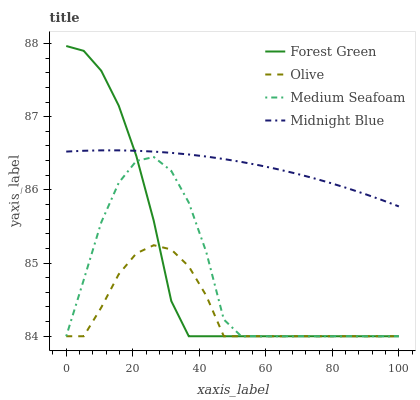Does Olive have the minimum area under the curve?
Answer yes or no. Yes. Does Midnight Blue have the maximum area under the curve?
Answer yes or no. Yes. Does Forest Green have the minimum area under the curve?
Answer yes or no. No. Does Forest Green have the maximum area under the curve?
Answer yes or no. No. Is Midnight Blue the smoothest?
Answer yes or no. Yes. Is Medium Seafoam the roughest?
Answer yes or no. Yes. Is Forest Green the smoothest?
Answer yes or no. No. Is Forest Green the roughest?
Answer yes or no. No. Does Olive have the lowest value?
Answer yes or no. Yes. Does Midnight Blue have the lowest value?
Answer yes or no. No. Does Forest Green have the highest value?
Answer yes or no. Yes. Does Medium Seafoam have the highest value?
Answer yes or no. No. Is Medium Seafoam less than Midnight Blue?
Answer yes or no. Yes. Is Midnight Blue greater than Olive?
Answer yes or no. Yes. Does Medium Seafoam intersect Olive?
Answer yes or no. Yes. Is Medium Seafoam less than Olive?
Answer yes or no. No. Is Medium Seafoam greater than Olive?
Answer yes or no. No. Does Medium Seafoam intersect Midnight Blue?
Answer yes or no. No. 